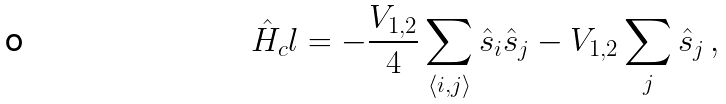Convert formula to latex. <formula><loc_0><loc_0><loc_500><loc_500>\hat { H } _ { c } l = - \frac { V _ { 1 , 2 } } { 4 } \sum _ { \langle i , j \rangle } \hat { s } _ { i } \hat { s } _ { j } - V _ { 1 , 2 } \sum _ { j } \hat { s } _ { j } \, ,</formula> 